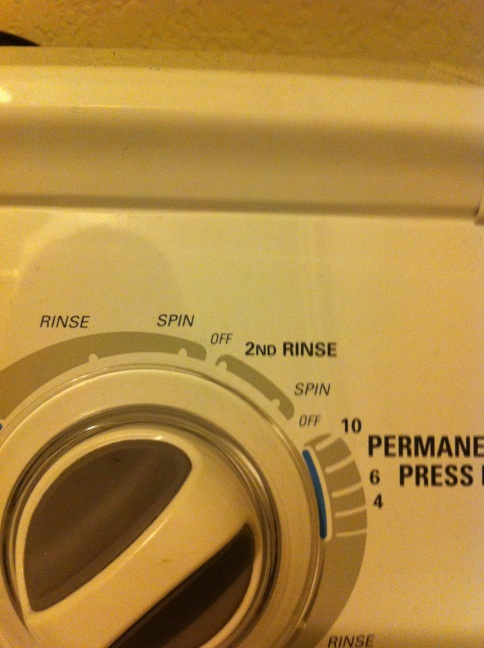If this washing machine could talk, what would it say about its job? If this washing machine could talk, it might say, 'I’m your friendly household helper, tirelessly working to ensure your clothes are clean, fresh, and ready to wear. With my various cycles like ‘Spin’, ‘Rinse’, and ‘2nd Rinse’, I tackle different cleaning needs and make sure your laundry is done just right! Don't forget to give me a bit of maintenance now and then to keep me operating smoothly!' 